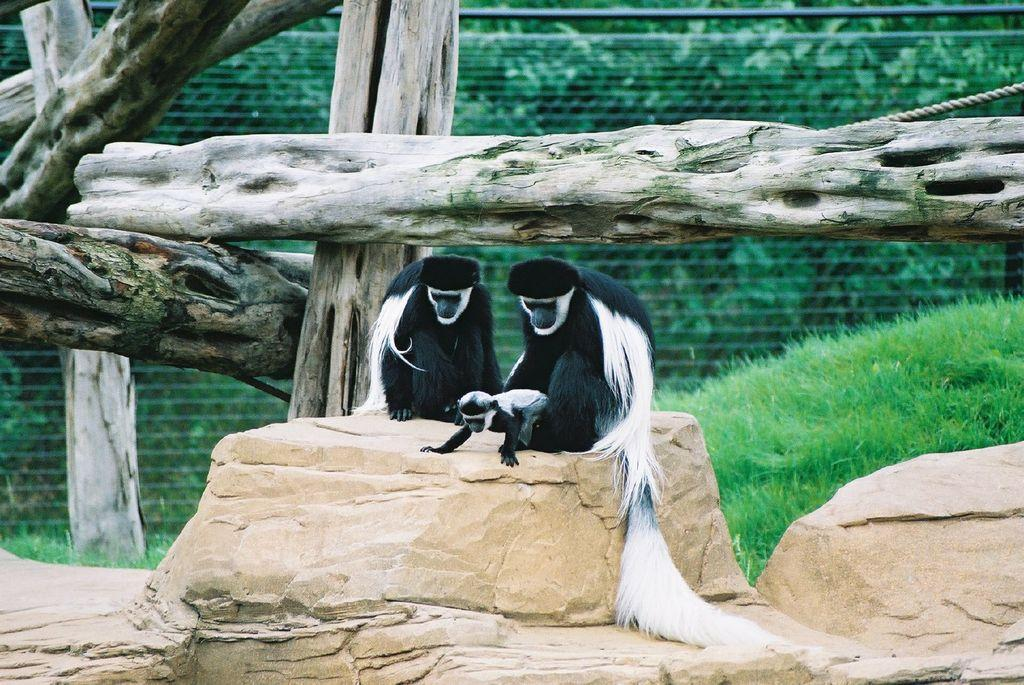What type of animals are in the image? There are black and white monkeys in the image. Where are the monkeys located? The monkeys are on a stone. What can be seen in the background of the image? There are tree trunks in the background of the image. What is on the ground in the image? There is grass on the ground in the image. What structure is present in the image? There is a wall in the image. What year is depicted in the image? The image does not depict a specific year; it is a photograph of monkeys on a stone. What type of food is being prepared in the image? There is no food preparation visible in the image; it features monkeys on a stone with a background of tree trunks and a wall. 